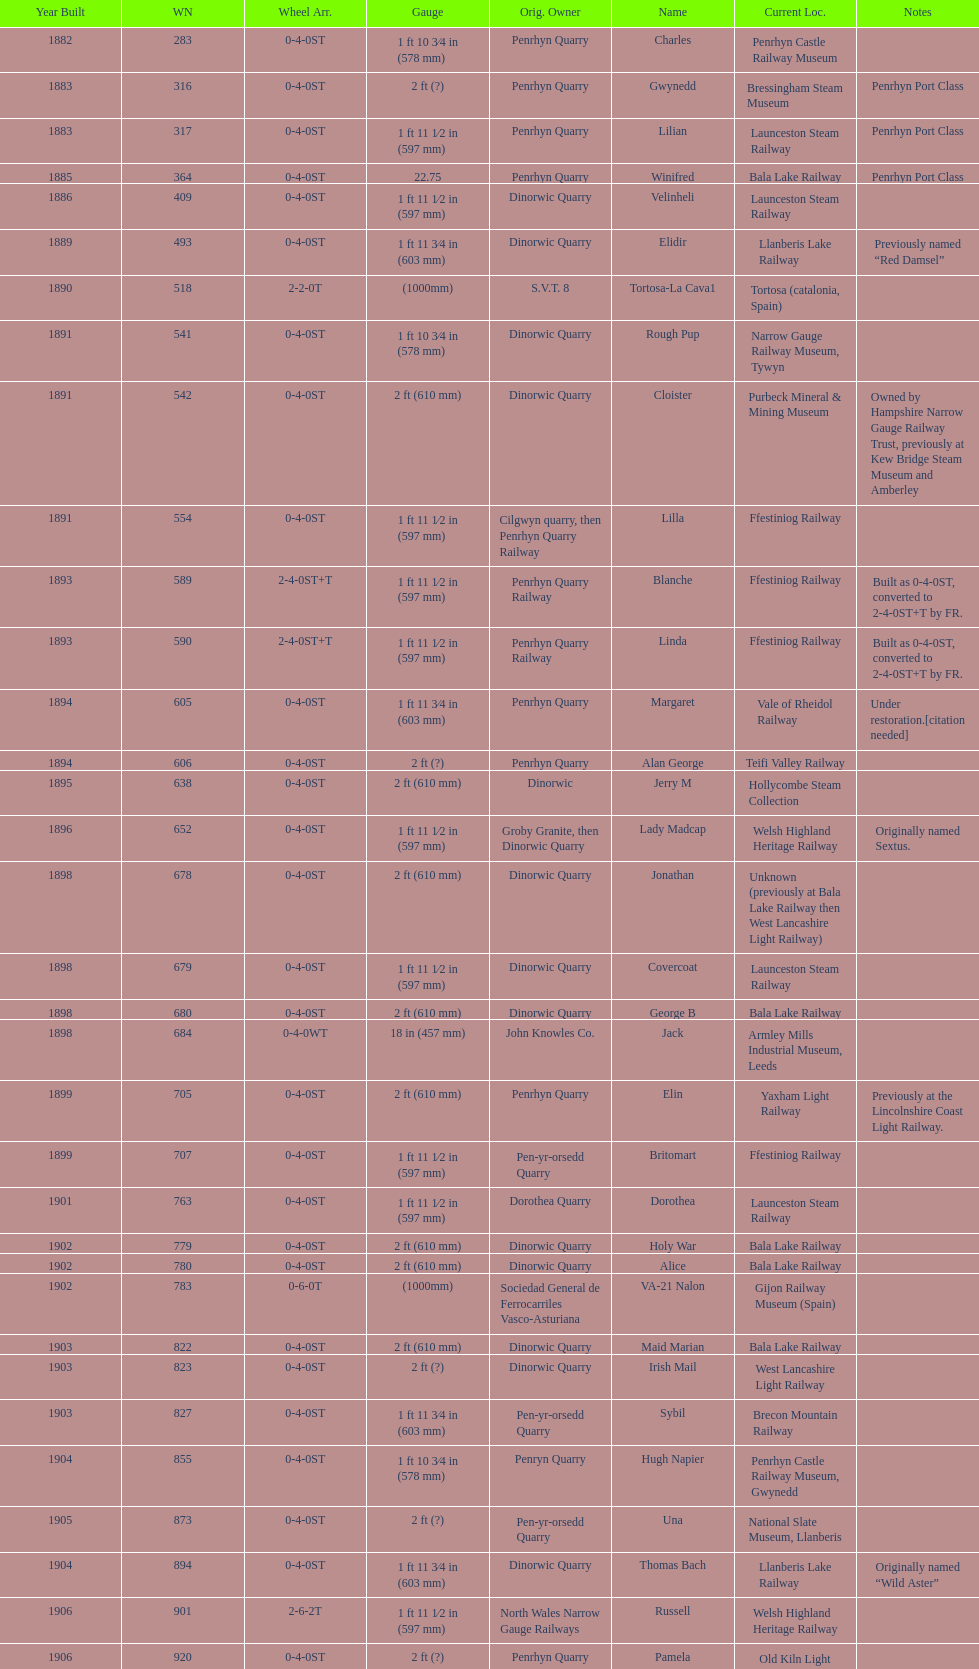What is the name of the last locomotive to be located at the bressingham steam museum? Gwynedd. 